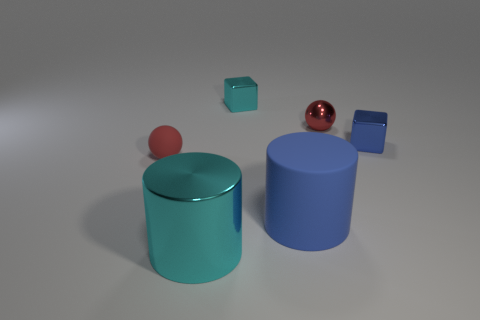How do the shapes of the objects in the image relate to each other? The image presents a variety of geometric forms, creating an interesting visual contrast. We have two prominent cylinders of varying sizes that provide a sense of symmetry. The blocks add to the complexity with their cubic shape, contrasting the rounded edges of the cylinders. Lastly, the sphere offers an interruption to the otherwise angular scene with its perfect roundness, creating a dynamic and balanced composition. 